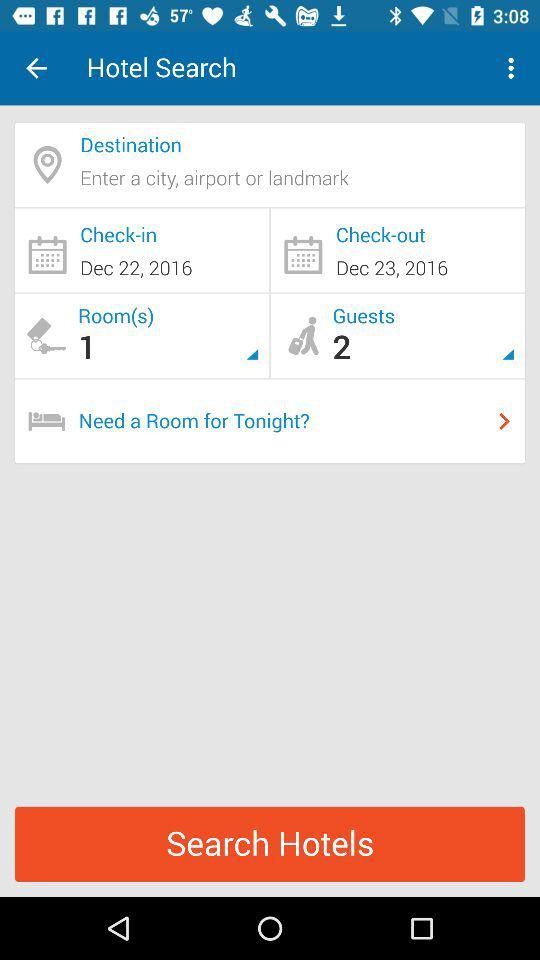How many days apart are the check-in and check-out dates?
Answer the question using a single word or phrase. 1 